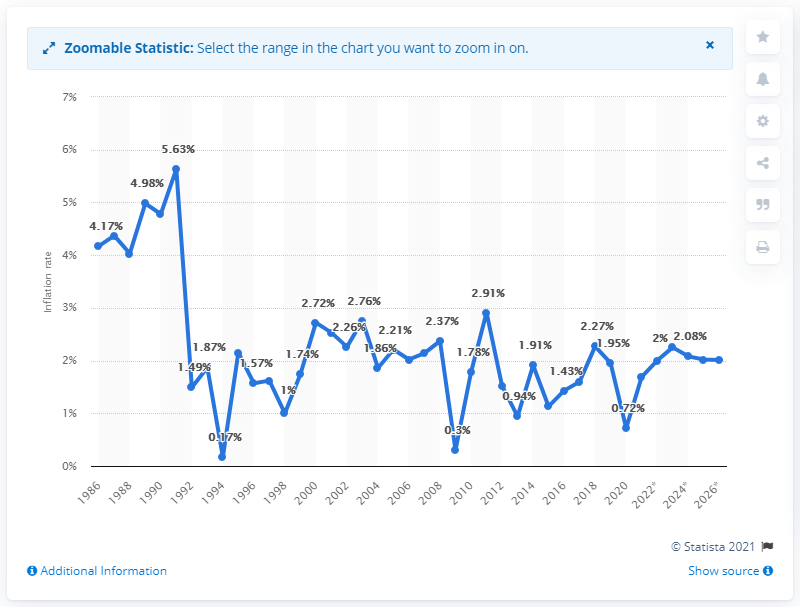Give some essential details in this illustration. The average inflation rate in Canada in 2020 was 0.72%. 